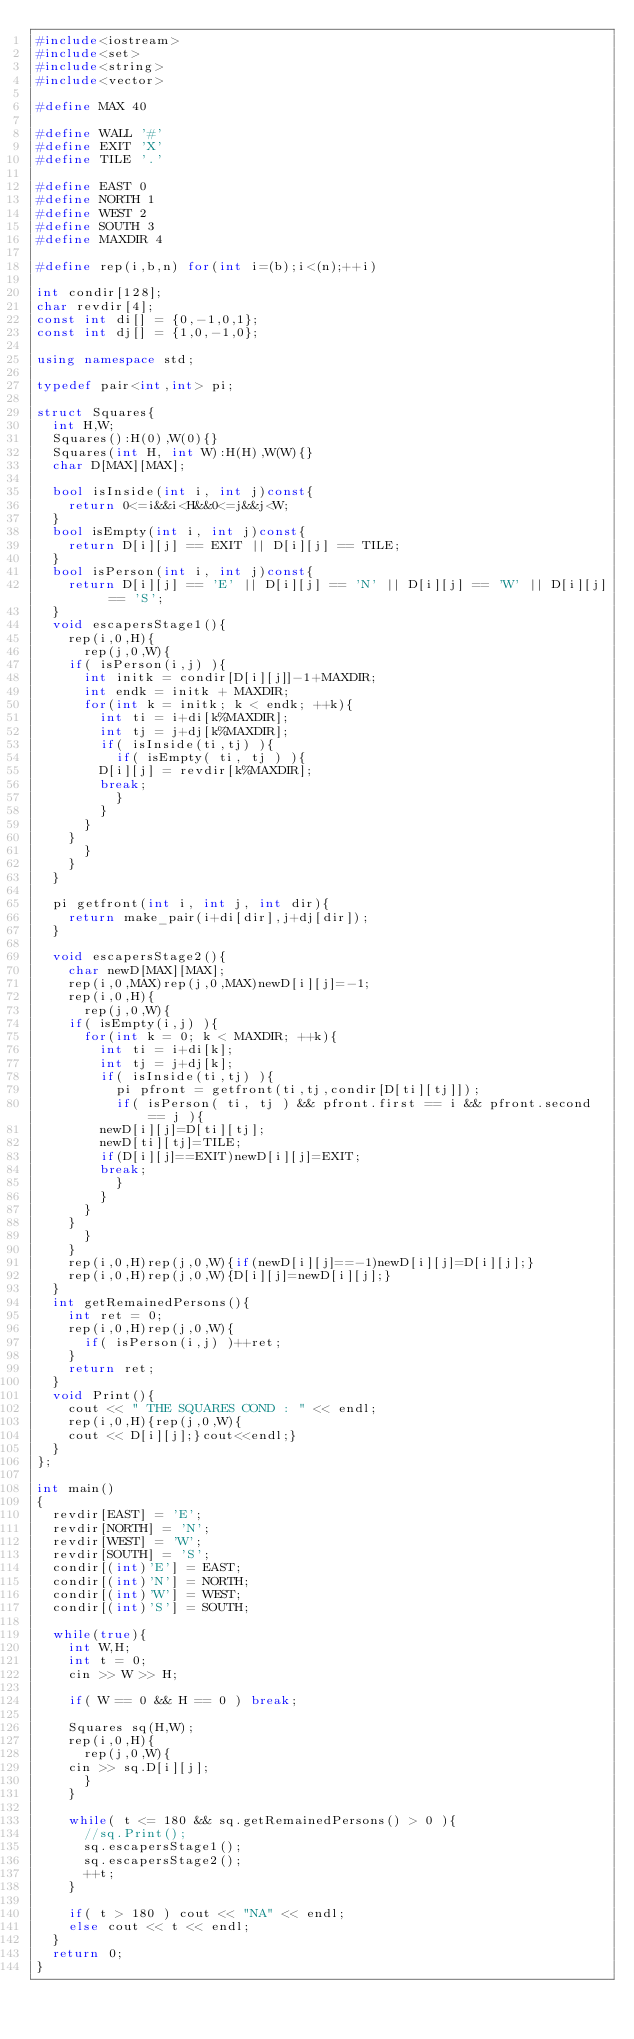<code> <loc_0><loc_0><loc_500><loc_500><_C++_>#include<iostream>
#include<set>
#include<string>
#include<vector>

#define MAX 40

#define WALL '#'
#define EXIT 'X'
#define TILE '.'

#define EAST 0
#define NORTH 1
#define WEST 2
#define SOUTH 3
#define MAXDIR 4

#define rep(i,b,n) for(int i=(b);i<(n);++i)

int condir[128];
char revdir[4];
const int di[] = {0,-1,0,1};
const int dj[] = {1,0,-1,0};

using namespace std;

typedef pair<int,int> pi;

struct Squares{
  int H,W;
  Squares():H(0),W(0){}
  Squares(int H, int W):H(H),W(W){}
  char D[MAX][MAX];

  bool isInside(int i, int j)const{
    return 0<=i&&i<H&&0<=j&&j<W;
  }
  bool isEmpty(int i, int j)const{
    return D[i][j] == EXIT || D[i][j] == TILE;
  }
  bool isPerson(int i, int j)const{
    return D[i][j] == 'E' || D[i][j] == 'N' || D[i][j] == 'W' || D[i][j] == 'S';
  }
  void escapersStage1(){
    rep(i,0,H){
      rep(j,0,W){
	if( isPerson(i,j) ){
	  int initk = condir[D[i][j]]-1+MAXDIR;
	  int endk = initk + MAXDIR;
	  for(int k = initk; k < endk; ++k){
	    int ti = i+di[k%MAXDIR];
	    int tj = j+dj[k%MAXDIR];
	    if( isInside(ti,tj) ){
	      if( isEmpty( ti, tj ) ){
		D[i][j] = revdir[k%MAXDIR];
		break;
	      }
	    }
	  }
	}
      }
    }
  }

  pi getfront(int i, int j, int dir){
    return make_pair(i+di[dir],j+dj[dir]);
  }
  
  void escapersStage2(){
    char newD[MAX][MAX];
    rep(i,0,MAX)rep(j,0,MAX)newD[i][j]=-1;
    rep(i,0,H){
      rep(j,0,W){
	if( isEmpty(i,j) ){
	  for(int k = 0; k < MAXDIR; ++k){
	    int ti = i+di[k];
	    int tj = j+dj[k];
	    if( isInside(ti,tj) ){
	      pi pfront = getfront(ti,tj,condir[D[ti][tj]]);
	      if( isPerson( ti, tj ) && pfront.first == i && pfront.second == j ){
		newD[i][j]=D[ti][tj];
		newD[ti][tj]=TILE;
		if(D[i][j]==EXIT)newD[i][j]=EXIT;
		break;
	      }
	    }
	  }
	}
      }
    }
    rep(i,0,H)rep(j,0,W){if(newD[i][j]==-1)newD[i][j]=D[i][j];}
    rep(i,0,H)rep(j,0,W){D[i][j]=newD[i][j];}
  }
  int getRemainedPersons(){
    int ret = 0;
    rep(i,0,H)rep(j,0,W){
      if( isPerson(i,j) )++ret;
    }
    return ret;
  }
  void Print(){
    cout << " THE SQUARES COND : " << endl;
    rep(i,0,H){rep(j,0,W){
	cout << D[i][j];}cout<<endl;}
  }
};

int main()
{
  revdir[EAST] = 'E';
  revdir[NORTH] = 'N';
  revdir[WEST] = 'W';
  revdir[SOUTH] = 'S';
  condir[(int)'E'] = EAST;
  condir[(int)'N'] = NORTH;
  condir[(int)'W'] = WEST;
  condir[(int)'S'] = SOUTH;

  while(true){
    int W,H;
    int t = 0;
    cin >> W >> H;

    if( W == 0 && H == 0 ) break;
    
    Squares sq(H,W);
    rep(i,0,H){
      rep(j,0,W){
	cin >> sq.D[i][j];
      }
    }
  
    while( t <= 180 && sq.getRemainedPersons() > 0 ){
      //sq.Print();
      sq.escapersStage1();
      sq.escapersStage2();
      ++t;
    }

    if( t > 180 ) cout << "NA" << endl;
    else cout << t << endl;
  }
  return 0;
}</code> 